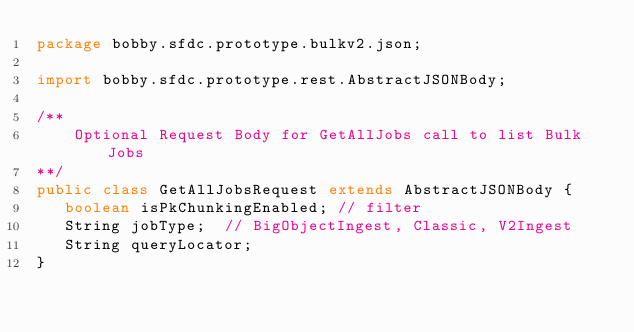<code> <loc_0><loc_0><loc_500><loc_500><_Java_>package bobby.sfdc.prototype.bulkv2.json;

import bobby.sfdc.prototype.rest.AbstractJSONBody;

/**
	Optional Request Body for GetAllJobs call to list Bulk Jobs
**/
public class GetAllJobsRequest extends AbstractJSONBody {
   boolean isPkChunkingEnabled; // filter
   String jobType;	// BigObjectIngest, Classic, V2Ingest
   String queryLocator;
}</code> 